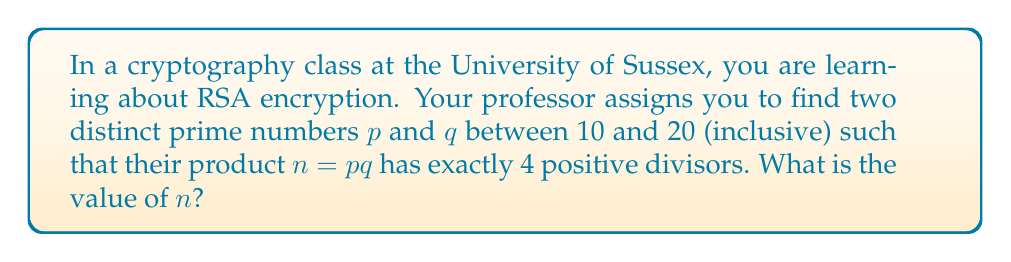Can you answer this question? Let's approach this step-by-step:

1) First, recall that the number of divisors of a number $n = pq$ where $p$ and $q$ are distinct primes is given by $(1+1)(1+1) = 4$. This is because the divisors are 1, $p$, $q$, and $pq$.

2) The prime numbers between 10 and 20 (inclusive) are:
   11, 13, 17, 19

3) We need to find a pair from these that when multiplied together, gives a product with exactly 4 divisors.

4) Let's try the combinations:
   
   11 × 13 = 143
   11 × 17 = 187
   11 × 19 = 209
   13 × 17 = 221
   13 × 19 = 247
   17 × 19 = 323

5) Any of these products will have exactly 4 divisors (1, the two prime factors, and the product itself).

6) The question asks for the value of $n$, which is the product $pq$. We can choose any of the above products.

7) For this answer, let's select the smallest product: 11 × 13 = 143.

Therefore, $n = 143$ satisfies all the conditions of the problem.
Answer: $n = 143$ 